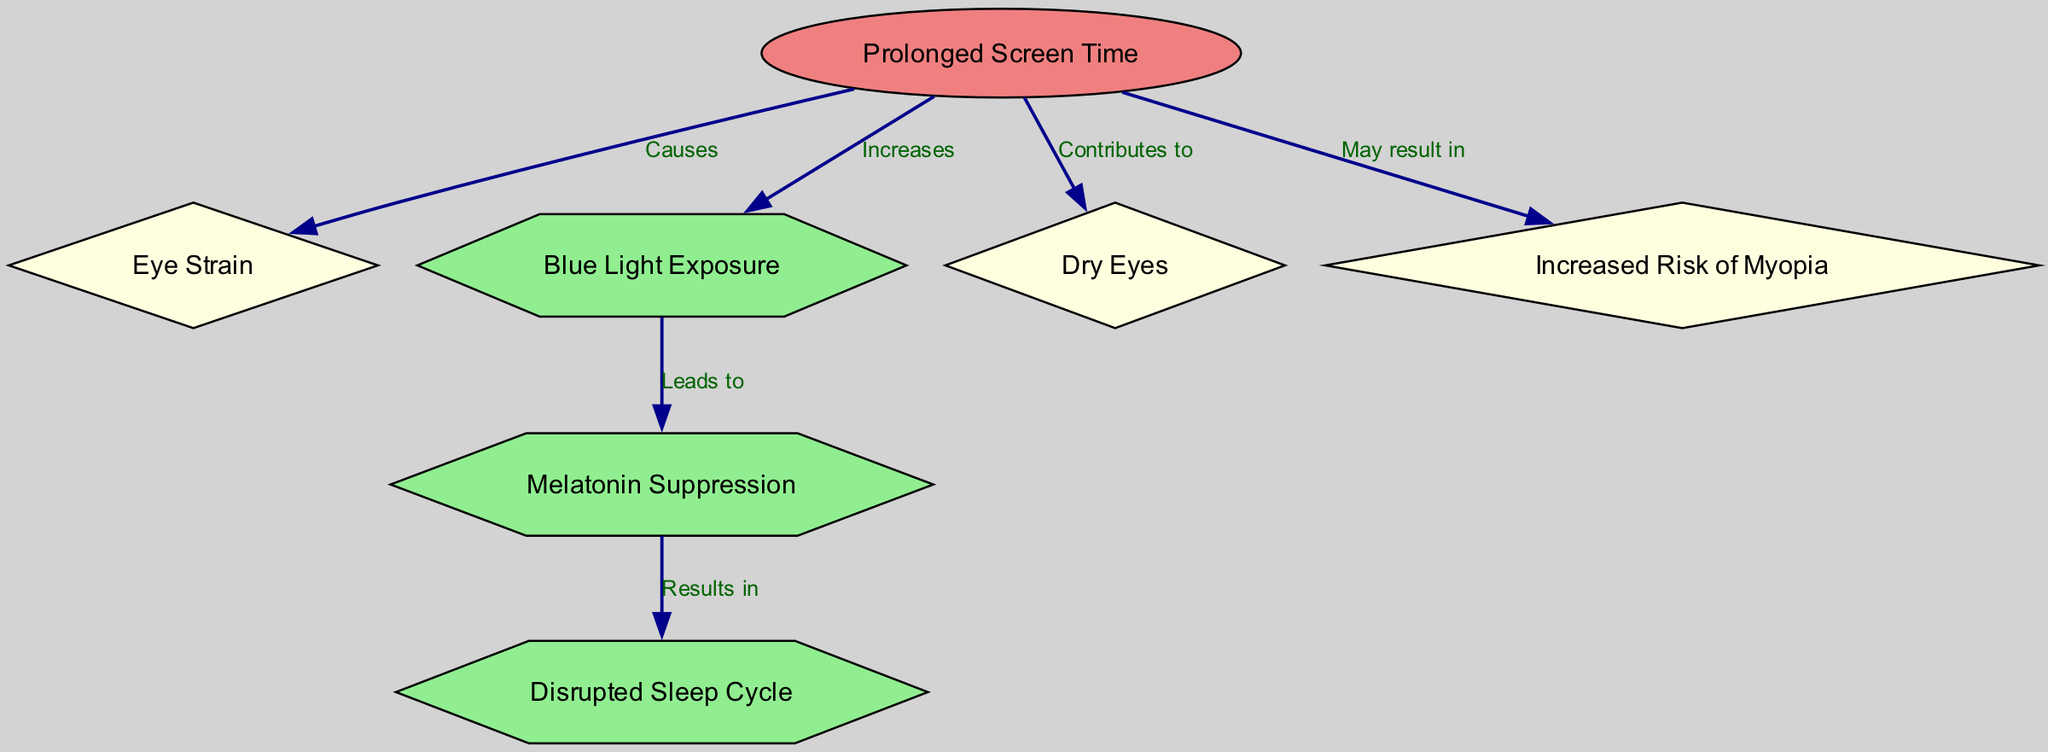What is the primary effect of prolonged screen time? The primary effect mentioned in the diagram is "Eye Strain," which is directly connected to the "Prolonged Screen Time" node as a cause.
Answer: Eye Strain How many nodes are present in the diagram? The diagram contains a total of 7 nodes which are labeled and represent different aspects related to screen time.
Answer: 7 What type of connection exists between "Blue Light Exposure" and "Melatonin Suppression"? The connection is labeled as "Leads to," indicating a causal relationship where increased blue light exposure results in melatonin suppression.
Answer: Leads to Which node indicates a consequence of prolonged screen time related to sleep? The node labeled "Disrupted Sleep Cycle" is a consequence related to the suppression of melatonin, which is caused by prolonged screen time.
Answer: Disrupted Sleep Cycle What can prolonged screen time contribute to, according to the diagram? The diagram lists "Dry Eyes" as one of the conditions that prolonged screen time contributes to, indicating a direct effect of excessive screen use.
Answer: Dry Eyes If prolonged screen time increases blue light exposure, what follows? Following the increase in blue light exposure, "Melatonin Suppression" occurs, which subsequently leads to a disrupted sleep cycle, showing the chain of effects.
Answer: Melatonin Suppression What is the visualization shape for "Prolonged Screen Time"? This node is depicted as an ellipse, which differentiates it from other nodes in terms of representation and indicates its primary status in the flowchart.
Answer: Ellipse How does prolonged screen time relate to the risk of myopia? The diagram specifies that prolonged screen time may result in increased risk of myopia, establishing a potential health risk associated with screen usage.
Answer: May result in Myopia Which node represents an effect that is not directly linked to sleep disturbances? The node labeled "Increased Risk of Myopia" is the effect mentioned that is not related to sleep disturbances but instead addresses a vision-related consequence.
Answer: Increased Risk of Myopia 